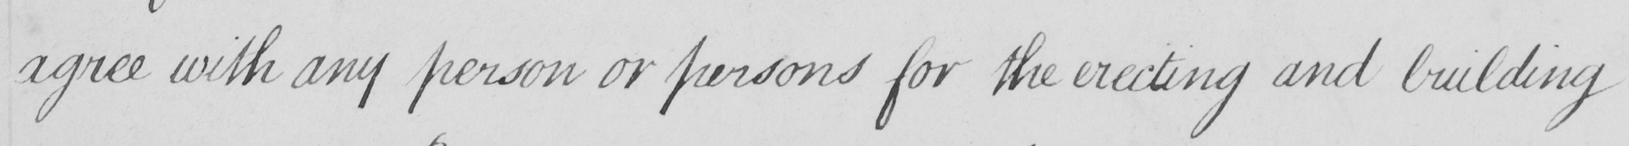What is written in this line of handwriting? agree with any person or persons for the erecting and building 